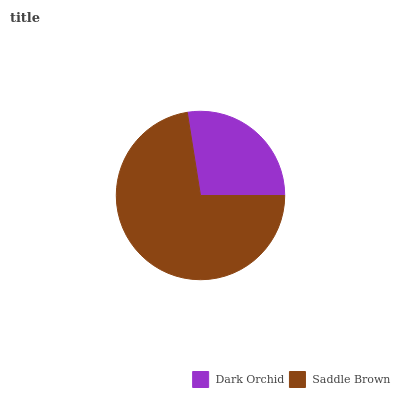Is Dark Orchid the minimum?
Answer yes or no. Yes. Is Saddle Brown the maximum?
Answer yes or no. Yes. Is Saddle Brown the minimum?
Answer yes or no. No. Is Saddle Brown greater than Dark Orchid?
Answer yes or no. Yes. Is Dark Orchid less than Saddle Brown?
Answer yes or no. Yes. Is Dark Orchid greater than Saddle Brown?
Answer yes or no. No. Is Saddle Brown less than Dark Orchid?
Answer yes or no. No. Is Saddle Brown the high median?
Answer yes or no. Yes. Is Dark Orchid the low median?
Answer yes or no. Yes. Is Dark Orchid the high median?
Answer yes or no. No. Is Saddle Brown the low median?
Answer yes or no. No. 